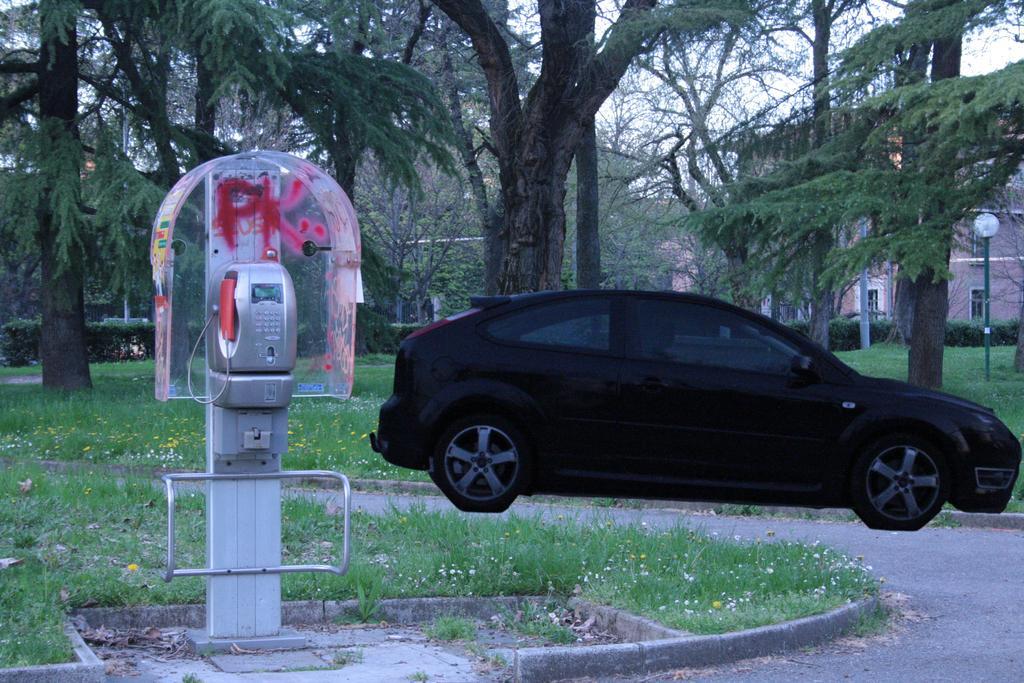In one or two sentences, can you explain what this image depicts? This image consists a car in black color. To the left, there is a telephone. At the bottom, there is green grass. In the background, there are many trees. 